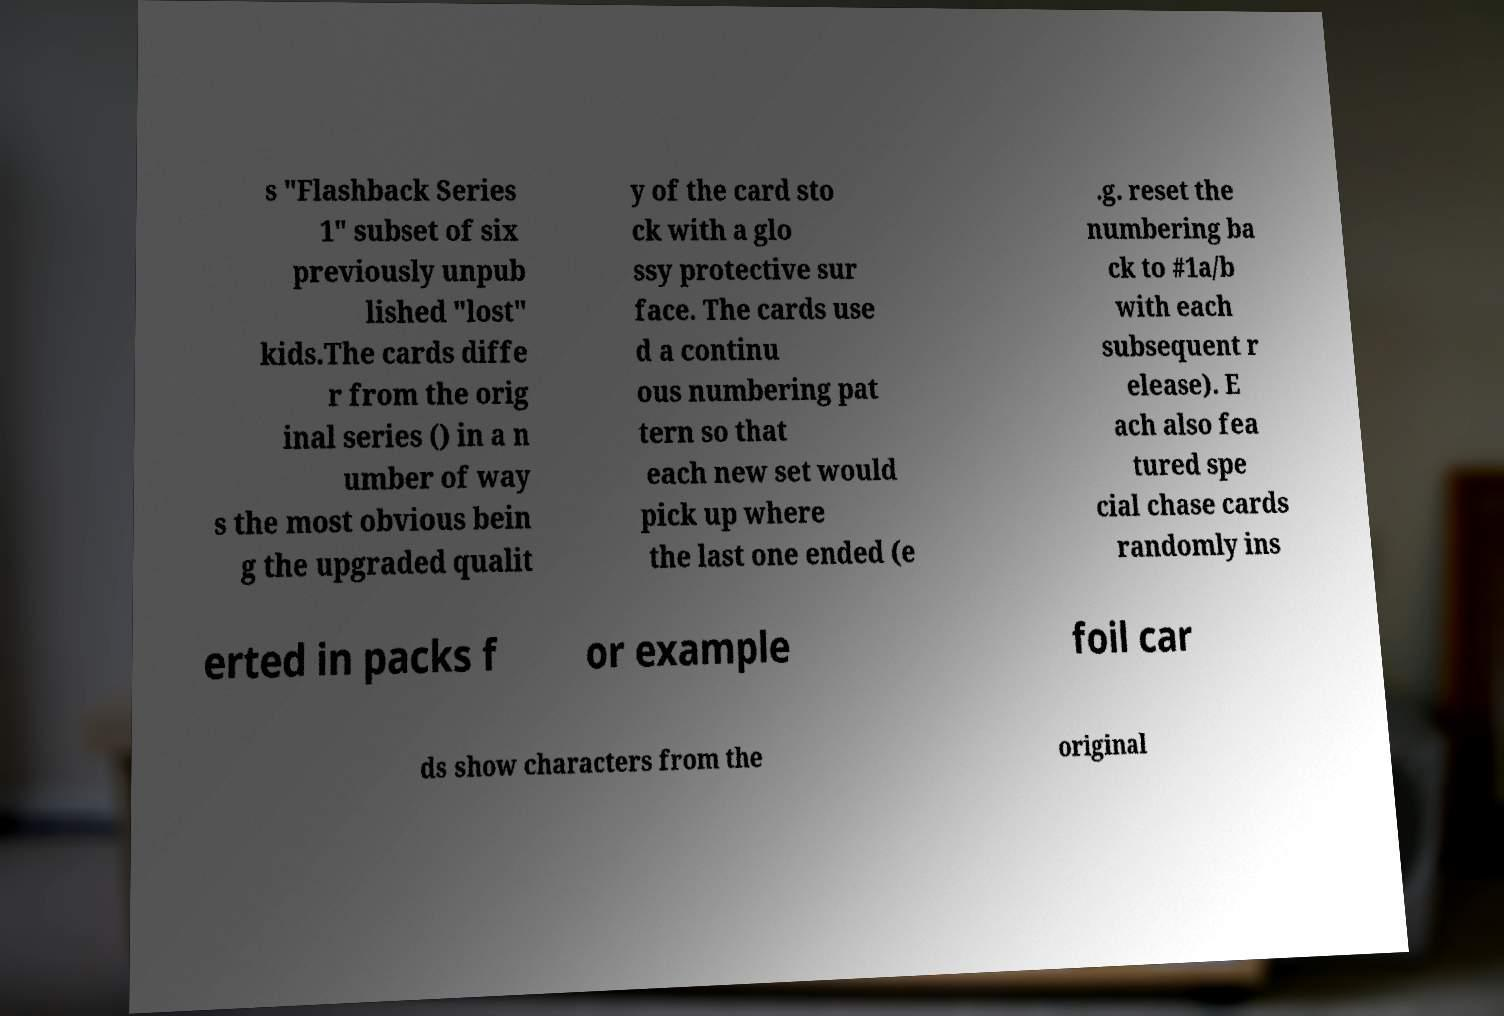There's text embedded in this image that I need extracted. Can you transcribe it verbatim? s "Flashback Series 1" subset of six previously unpub lished "lost" kids.The cards diffe r from the orig inal series () in a n umber of way s the most obvious bein g the upgraded qualit y of the card sto ck with a glo ssy protective sur face. The cards use d a continu ous numbering pat tern so that each new set would pick up where the last one ended (e .g. reset the numbering ba ck to #1a/b with each subsequent r elease). E ach also fea tured spe cial chase cards randomly ins erted in packs f or example foil car ds show characters from the original 